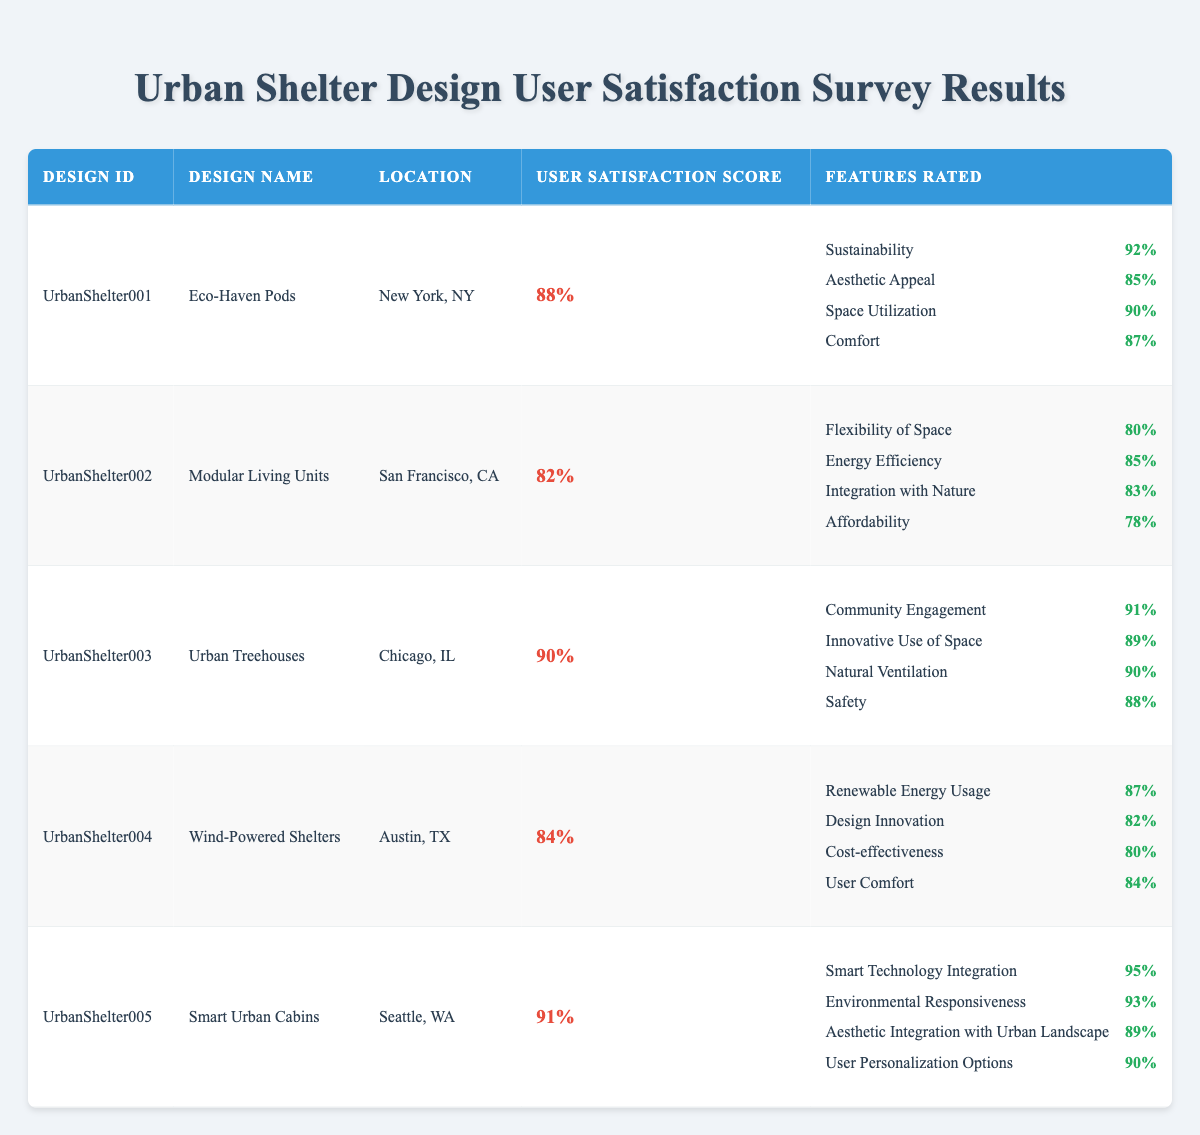What is the user satisfaction score for Eco-Haven Pods? The score is explicitly listed in the table under the "User Satisfaction Score" column for Eco-Haven Pods, which is 88%.
Answer: 88% Which design received the highest rating for Smart Technology Integration? The design Smart Urban Cabins received the rating of 95% for Smart Technology Integration, which is the highest among all designs listed.
Answer: 95% Is the user satisfaction score for Modular Living Units above 80%? Based on the table, the user satisfaction score for Modular Living Units is 82%, which confirms that it is above 80%.
Answer: Yes What is the average user satisfaction score for the designs listed? The scores are 88, 82, 90, 84, and 91. Summing these gives 88 + 82 + 90 + 84 + 91 = 435. Dividing by the number of designs (5) results in an average score of 87%.
Answer: 87% Which design has the lowest rating for Affordability? The design with the lowest rating for Affordability is Modular Living Units, which received a rating of 78%.
Answer: 78% What is the difference in user satisfaction scores between Smart Urban Cabins and Urban Treehouses? Smart Urban Cabins has a user satisfaction score of 91%, and Urban Treehouses has a score of 90%. The difference is 91 - 90 = 1.
Answer: 1 Does Wind-Powered Shelters have a higher rating for User Comfort compared to the rating for Energy Efficiency in Modular Living Units? Wind-Powered Shelters scored 84% for User Comfort, while Modular Living Units scored 85% for Energy Efficiency. Since 84% is less than 85%, Wind-Powered Shelters has a lower rating.
Answer: No Which feature received the highest rating in Smart Urban Cabins? The feature that received the highest rating in Smart Urban Cabins is Smart Technology Integration, which is rated at 95%.
Answer: 95% What can be inferred about the user satisfaction score trends across urban shelter designs? By reviewing the user satisfaction scores (88, 82, 90, 84, 91), it indicates a generally positive trend with most scores being above 80%, suggesting overall acceptance and satisfaction with the designs. However, there was a slight drop for Modular Living Units compared to the others.
Answer: Generally positive trend with slight drop for Modular Living Units 